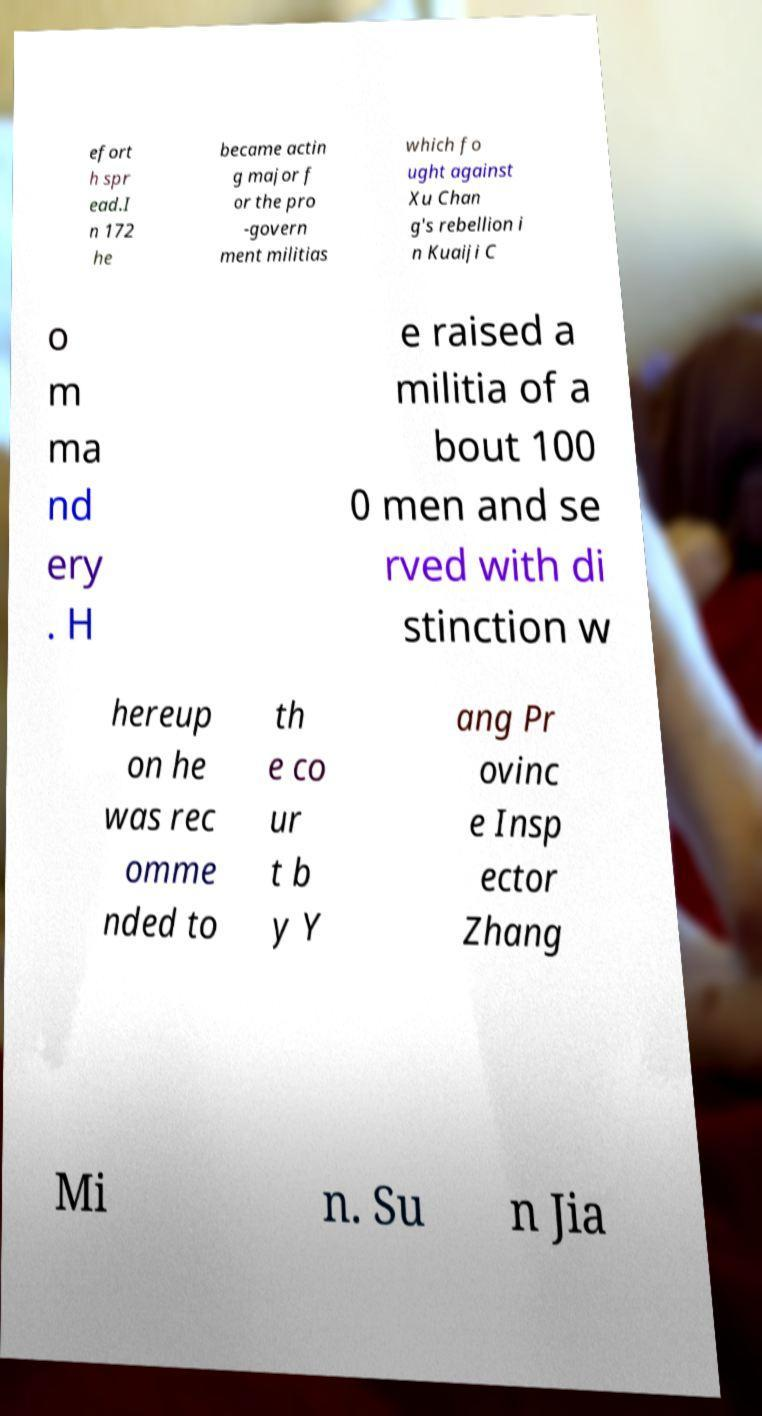Could you extract and type out the text from this image? efort h spr ead.I n 172 he became actin g major f or the pro -govern ment militias which fo ught against Xu Chan g's rebellion i n Kuaiji C o m ma nd ery . H e raised a militia of a bout 100 0 men and se rved with di stinction w hereup on he was rec omme nded to th e co ur t b y Y ang Pr ovinc e Insp ector Zhang Mi n. Su n Jia 